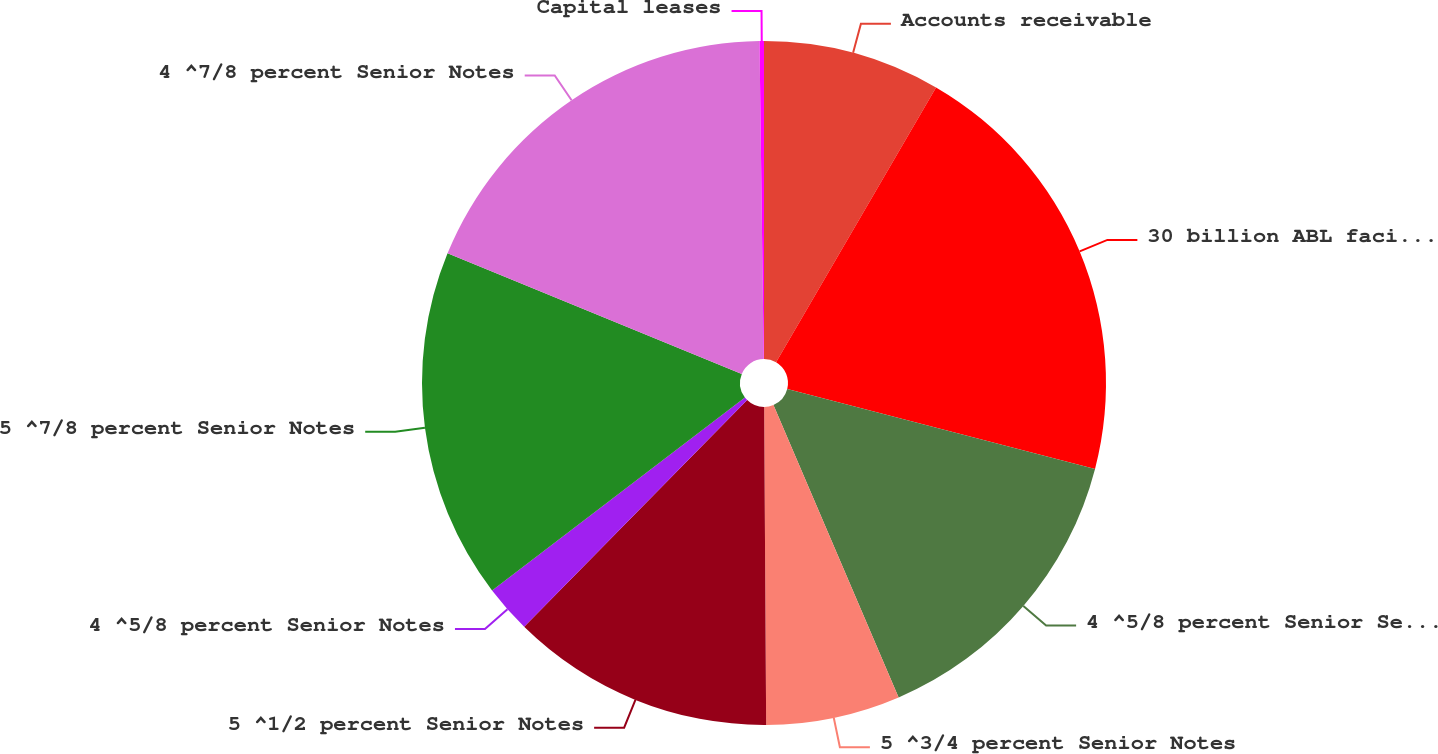<chart> <loc_0><loc_0><loc_500><loc_500><pie_chart><fcel>Accounts receivable<fcel>30 billion ABL facility<fcel>4 ^5/8 percent Senior Secured<fcel>5 ^3/4 percent Senior Notes<fcel>5 ^1/2 percent Senior Notes<fcel>4 ^5/8 percent Senior Notes<fcel>5 ^7/8 percent Senior Notes<fcel>4 ^7/8 percent Senior Notes<fcel>Capital leases<nl><fcel>8.39%<fcel>20.65%<fcel>14.52%<fcel>6.34%<fcel>12.47%<fcel>2.26%<fcel>16.56%<fcel>18.6%<fcel>0.21%<nl></chart> 